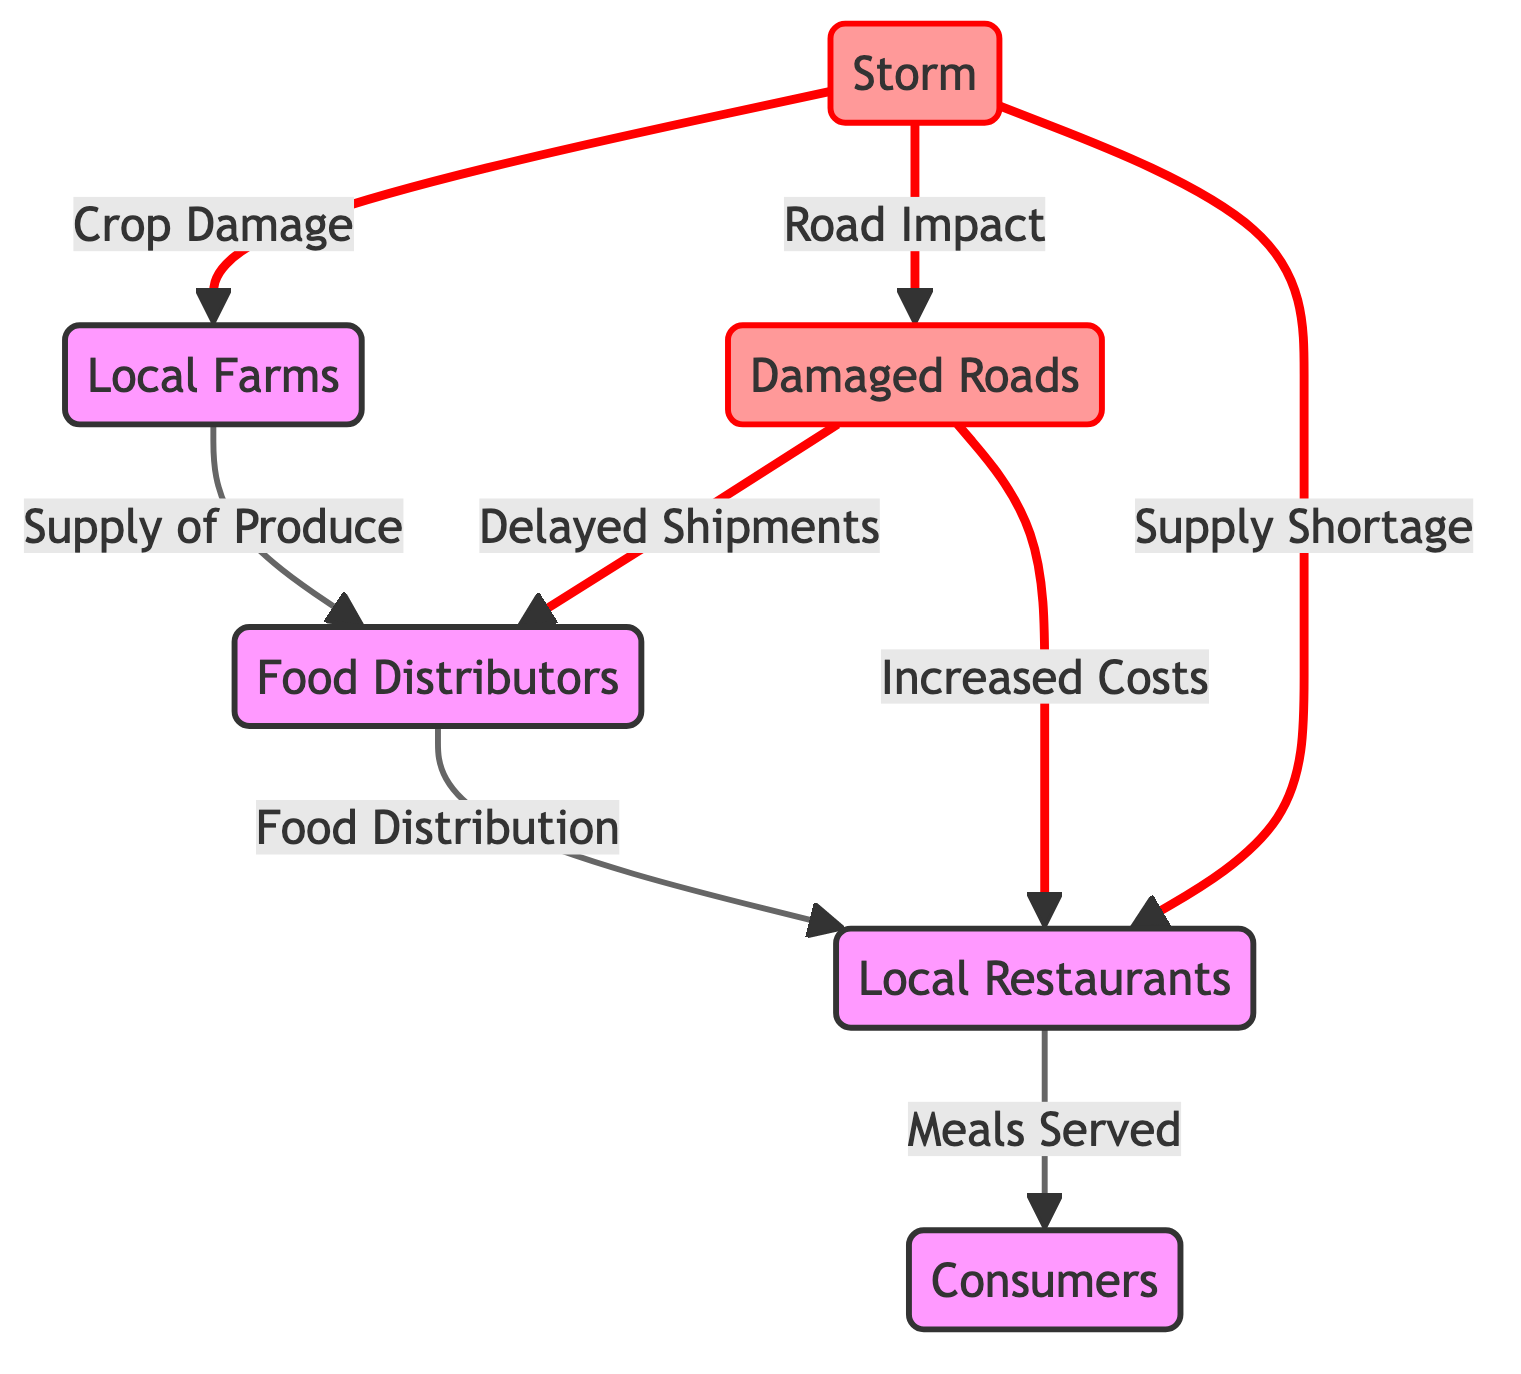What is the first node in the food chain? The first node in the food chain is "Local Farms", which supplies produce to the food distribution network.
Answer: Local Farms What do the distributors provide to the restaurants? The distributors provide food distribution to the restaurants, ensuring they receive necessary ingredients for their meals.
Answer: Food Distribution How many impact nodes are present in the diagram? There are three impact nodes indicated, which are "Storm", "Damaged Roads", and "Supply Shortage".
Answer: 3 What is the relationship between the storm and the farms? The storm causes crop damage to the farms, impacting their ability to supply produce to the distributors.
Answer: Crop Damage How does road damage affect the distributors? Road damage leads to delayed shipments from the distributors, creating disruptions in the food supply chain.
Answer: Delayed Shipments What effect does the storm have directly on local restaurants? The storm causes a supply shortage for local restaurants, resulting in fewer available ingredients for meal preparation.
Answer: Supply Shortage What is the final output of the chain for consumers? The final output for consumers from the chain is meals served, which they receive from local restaurants.
Answer: Meals Served How does the storm indirectly influence costs at restaurants? The storm causes road damage that leads to increased costs for restaurants, likely due to emergencies and sourcing alternative supplies.
Answer: Increased Costs What is the role of local farms in the supply chain? Local farms are responsible for supplying fresh produce to distributors, which forms the first link in the food chain.
Answer: Supply of Produce 